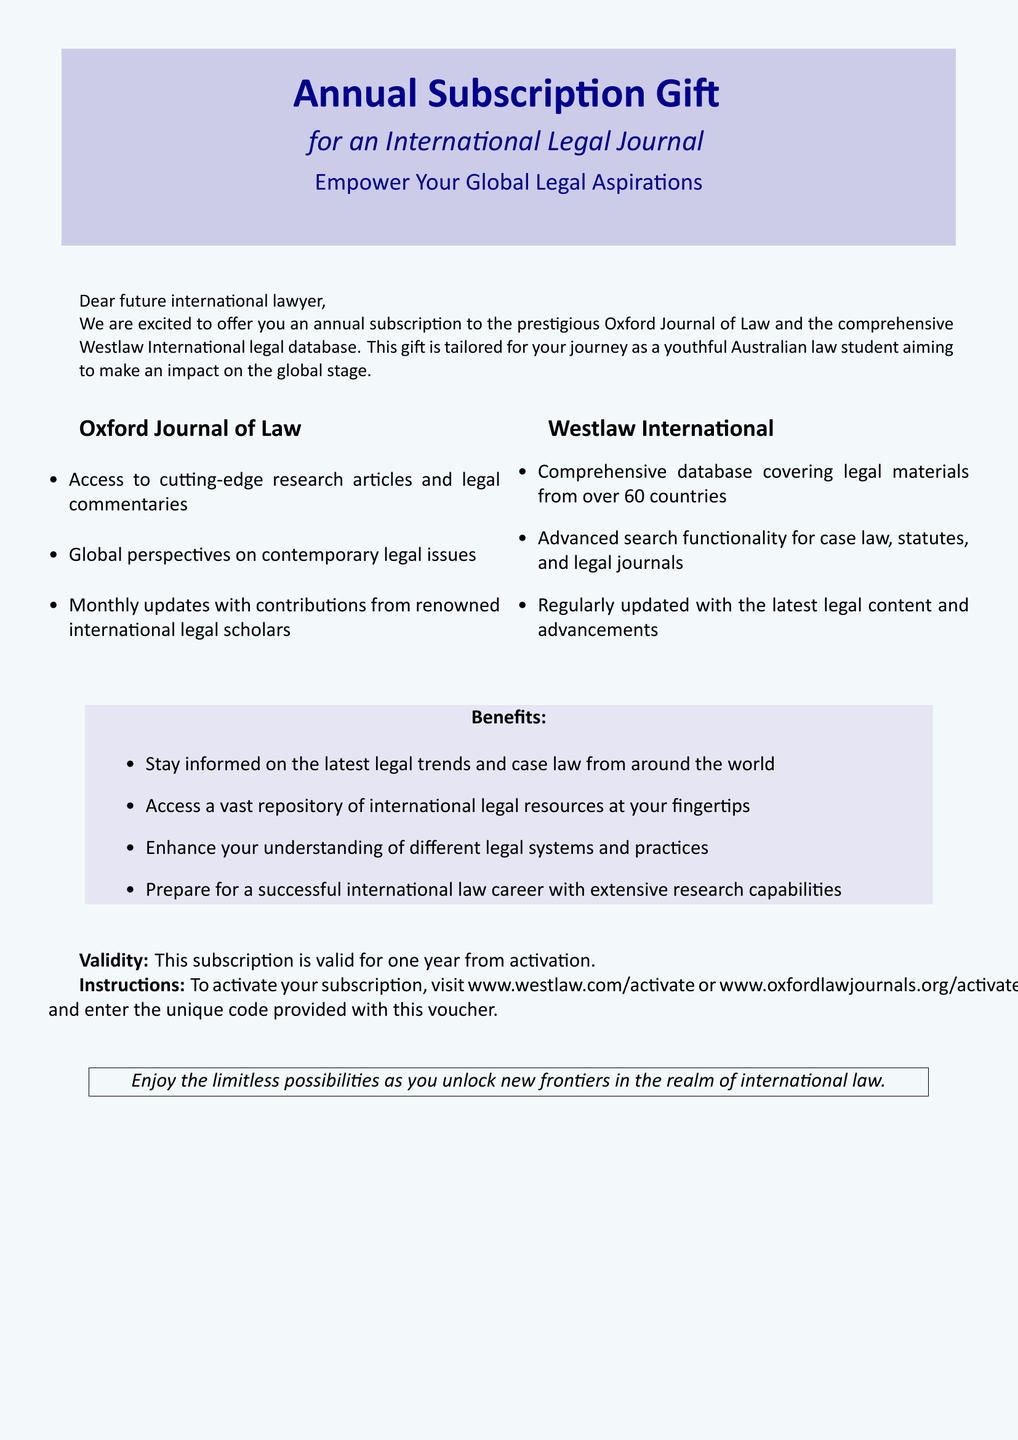What journal is included in the subscription? The document explicitly states that the subscription includes the prestigious Oxford Journal of Law.
Answer: Oxford Journal of Law How long is the subscription valid? The document specifies that the subscription is valid for one year from activation.
Answer: One year Which online legal database is mentioned? The document mentions the Westlaw International legal database as part of the gift.
Answer: Westlaw International What does the subscription offer access to? The document lists access to cutting-edge research articles and legal commentaries as part of the subscription.
Answer: Cutting-edge research articles and legal commentaries What is required to activate the subscription? The document outlines that a unique code provided with the voucher needs to be entered to activate the subscription.
Answer: Unique code What type of resources can you access with Westlaw International? The document indicates that Westlaw International covers legal materials from over 60 countries.
Answer: Legal materials from over 60 countries What is a benefit of the Oxford Journal of Law subscription? The document mentions staying informed on the latest legal trends and case law from around the world as a benefit.
Answer: Stay informed on the latest legal trends Where can you find the activation instructions? The document states that activation instructions can be found at www.westlaw.com/activate or www.oxfordlawjournals.org/activate.
Answer: www.westlaw.com/activate or www.oxfordlawjournals.org/activate What kind of legal issues does the Journal provide perspectives on? The document describes that the journal provides global perspectives on contemporary legal issues.
Answer: Contemporary legal issues 